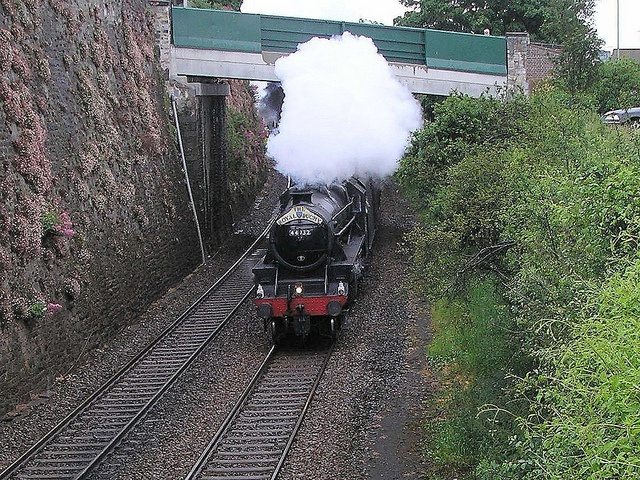Describe the objects in this image and their specific colors. I can see train in black, gray, darkgray, and maroon tones and car in black, gray, darkgray, and white tones in this image. 